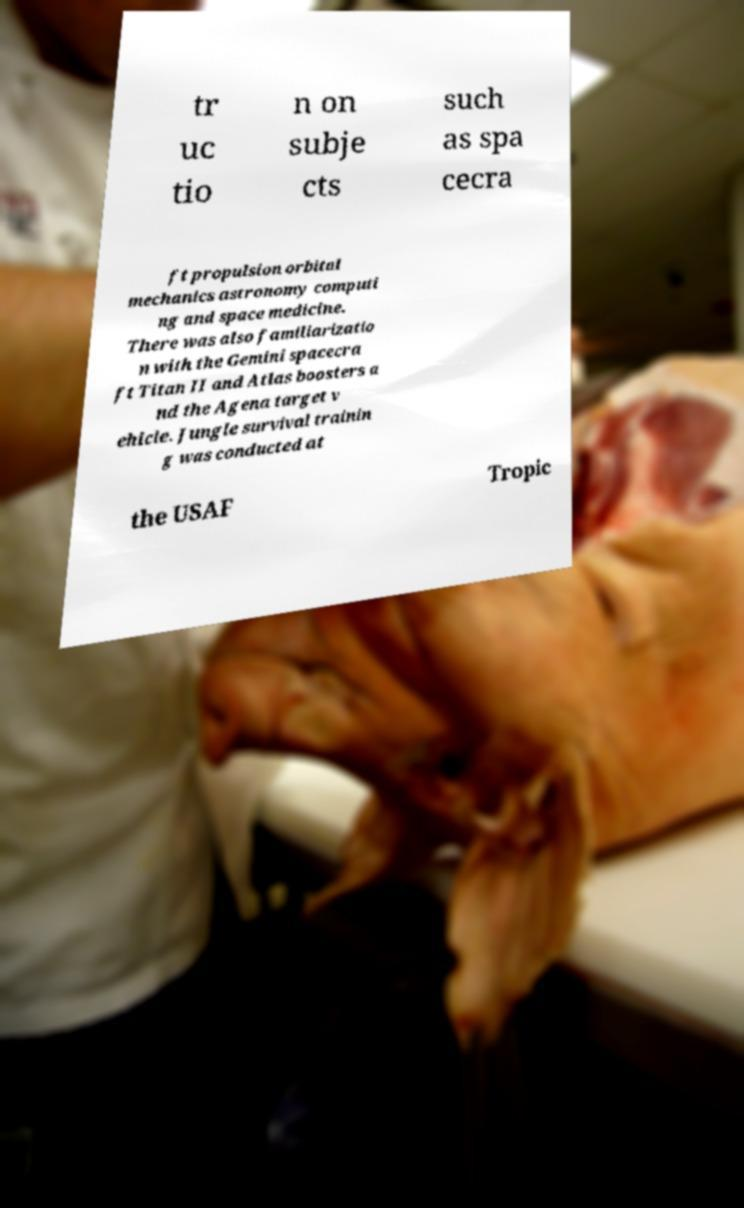I need the written content from this picture converted into text. Can you do that? tr uc tio n on subje cts such as spa cecra ft propulsion orbital mechanics astronomy computi ng and space medicine. There was also familiarizatio n with the Gemini spacecra ft Titan II and Atlas boosters a nd the Agena target v ehicle. Jungle survival trainin g was conducted at the USAF Tropic 